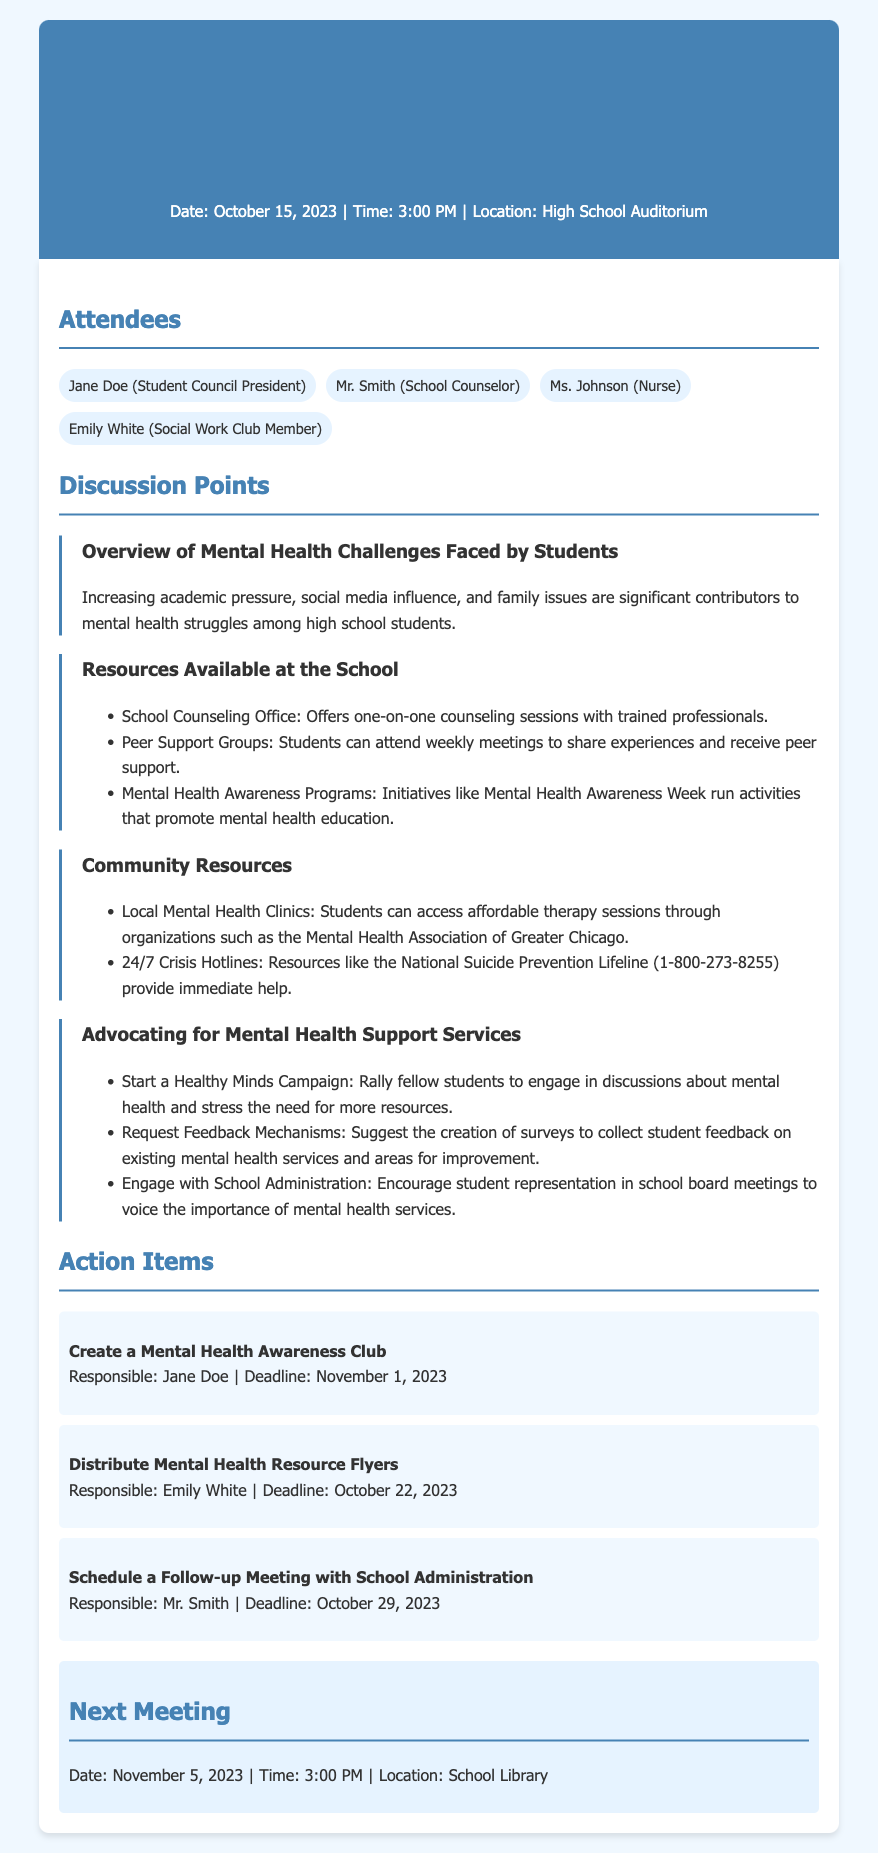What is the date of the meeting? The date of the meeting is stated in the header.
Answer: October 15, 2023 Who is the School Counselor? The name of the School Counselor is mentioned in the attendees section.
Answer: Mr. Smith What is one community resource listed? The document lists specific community resources under a discussion point.
Answer: Local Mental Health Clinics What campaign is suggested for advocating mental health support? The document mentions a specific campaign aimed at advocacy.
Answer: Healthy Minds Campaign What is the deadline for creating the Mental Health Awareness Club? The deadline for this action item is found in the action items section.
Answer: November 1, 2023 What is the location of the next meeting? The next meeting's location is indicated towards the end of the document.
Answer: School Library How often do Peer Support Groups meet? The frequency of the Peer Support Groups is mentioned in the resources section.
Answer: Weekly Who is responsible for distributing Mental Health Resource Flyers? The action items specify who is responsible for this task.
Answer: Emily White 